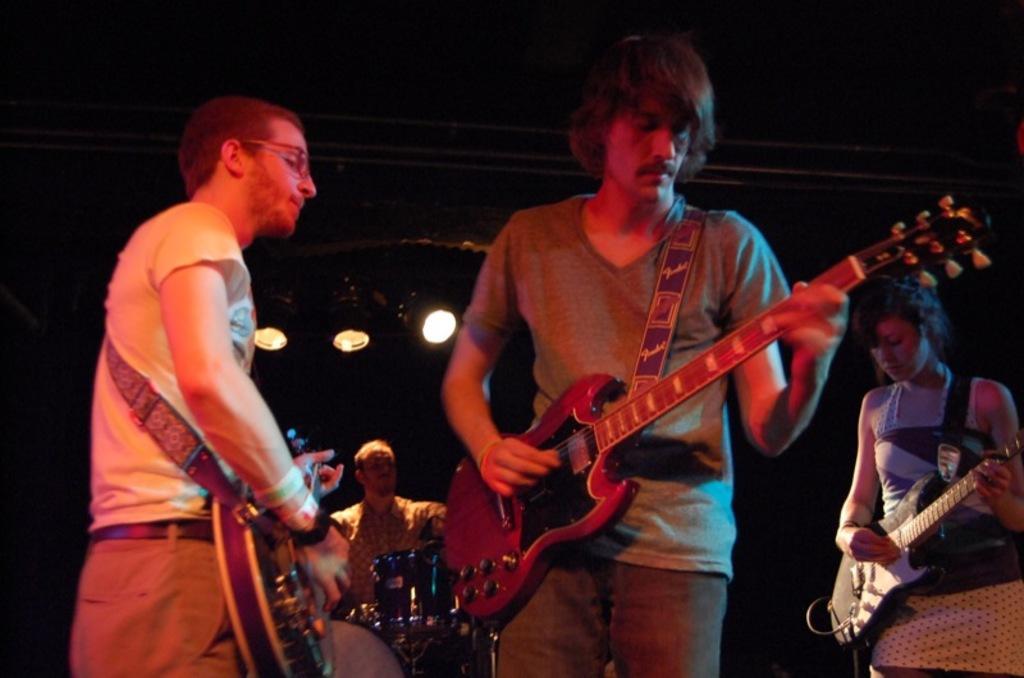How would you summarize this image in a sentence or two? In the picture there are four people and at the right corner of the picture one woman is playing a guitar and in the left corner of the picture one man is playing a guitar and wearing glasses, white shirt and pant. In the middle of the picture the person is playing a guitar wearing a grey t-shirt and jeans behind them there is a person sitting on the chair and playing the drums and the background is very dark and there are three lights on top of them. 